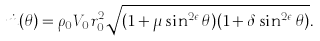Convert formula to latex. <formula><loc_0><loc_0><loc_500><loc_500>\dot { m } ( \theta ) = \rho _ { 0 } V _ { 0 } r _ { 0 } ^ { 2 } \sqrt { ( 1 + \mu \sin ^ { 2 \epsilon } \theta ) ( 1 + \delta \sin ^ { 2 \epsilon } \theta ) } .</formula> 